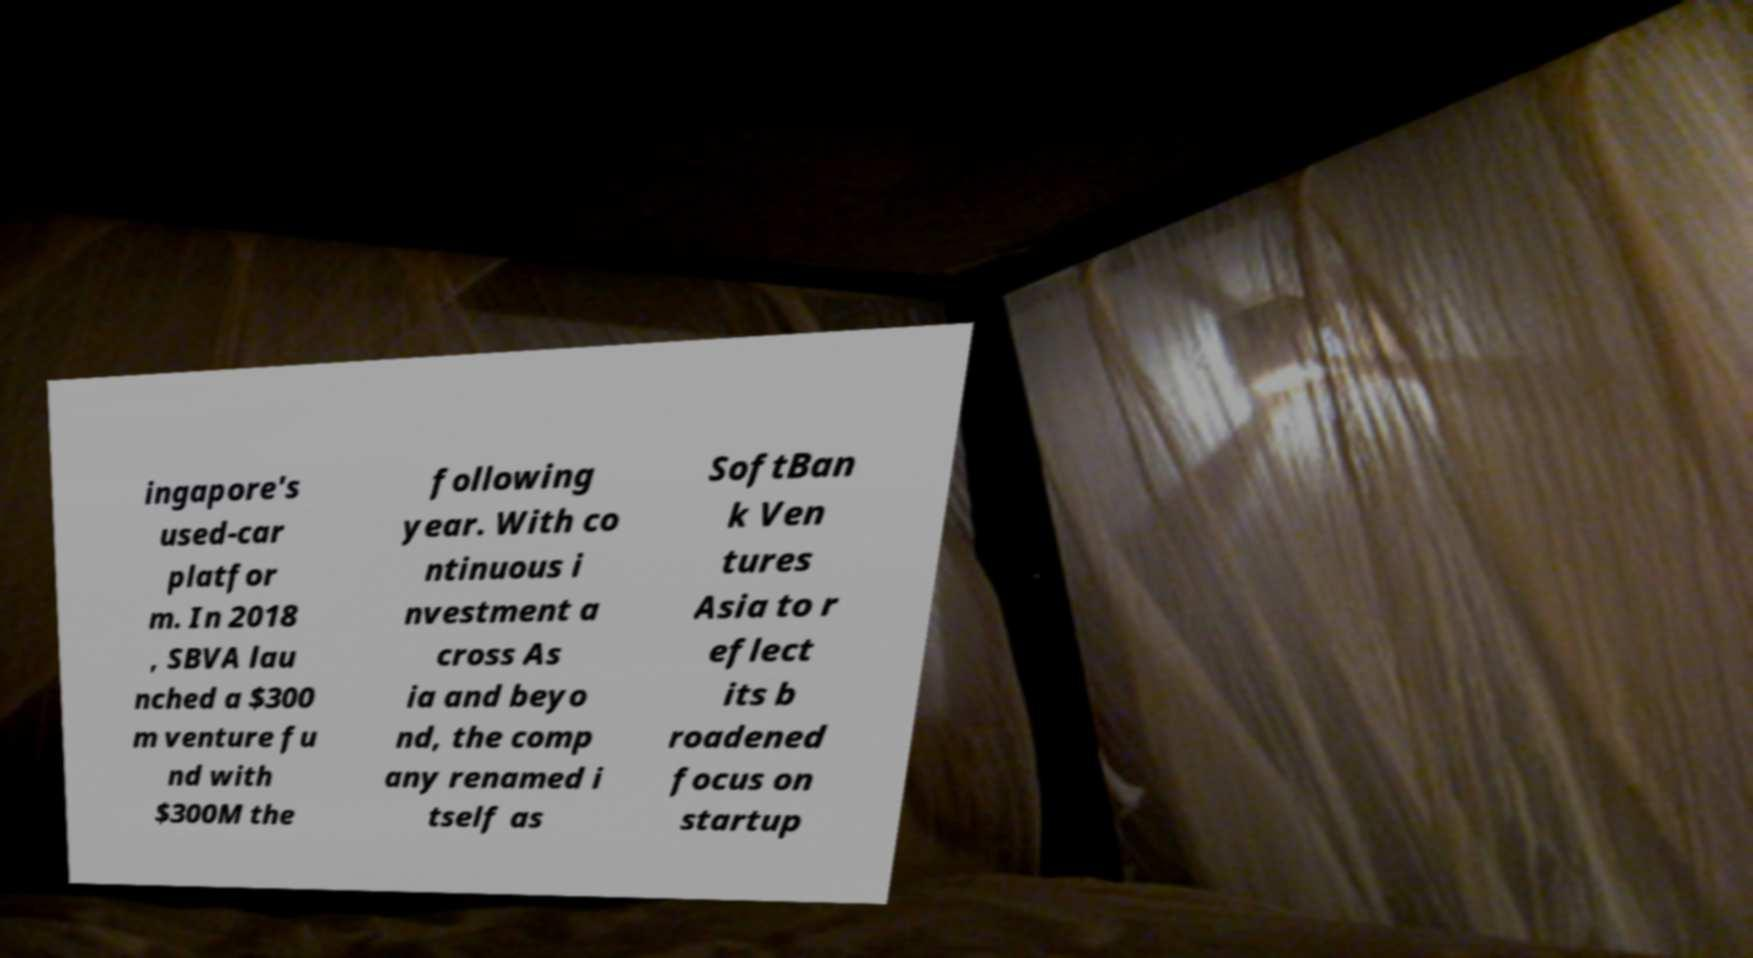Please read and relay the text visible in this image. What does it say? ingapore's used-car platfor m. In 2018 , SBVA lau nched a $300 m venture fu nd with $300M the following year. With co ntinuous i nvestment a cross As ia and beyo nd, the comp any renamed i tself as SoftBan k Ven tures Asia to r eflect its b roadened focus on startup 